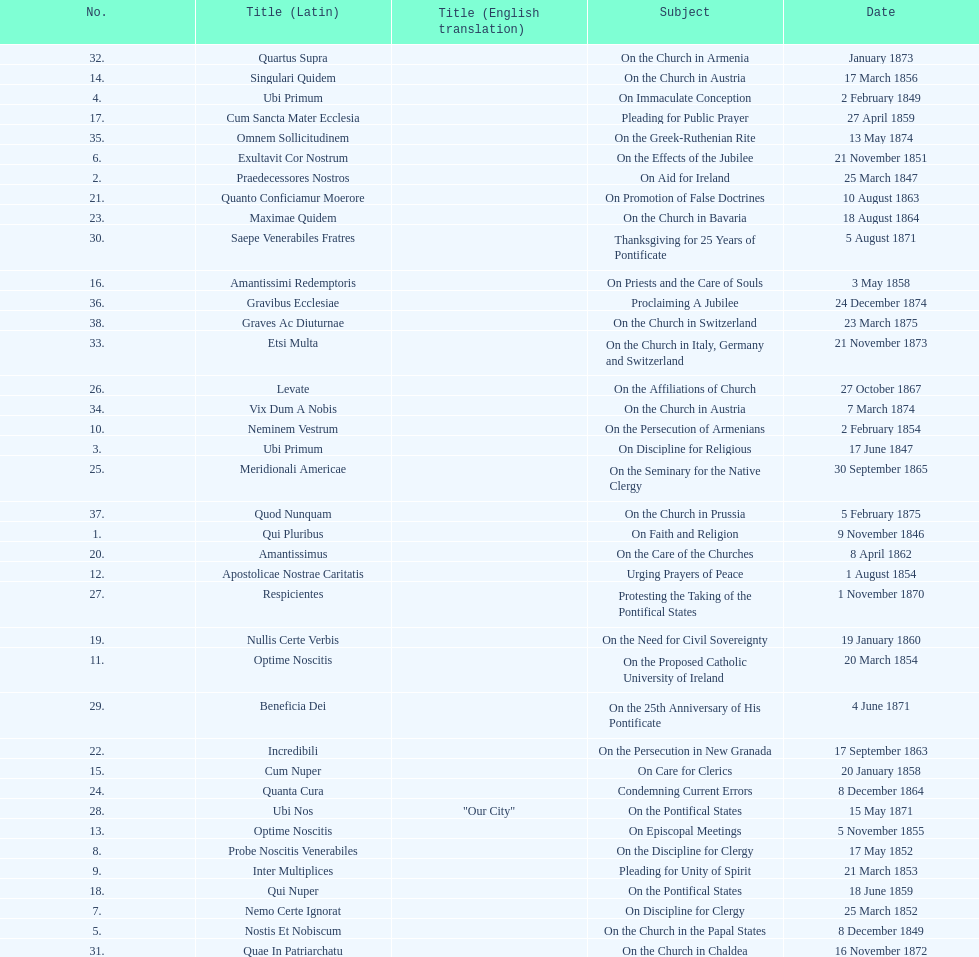In the first 10 years of his reign, how many encyclicals did pope pius ix issue? 14. 